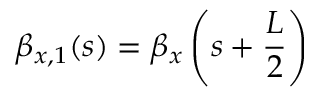<formula> <loc_0><loc_0><loc_500><loc_500>\beta _ { x , 1 } ( s ) = \beta _ { x } \left ( s + \frac { L } { 2 } \right )</formula> 